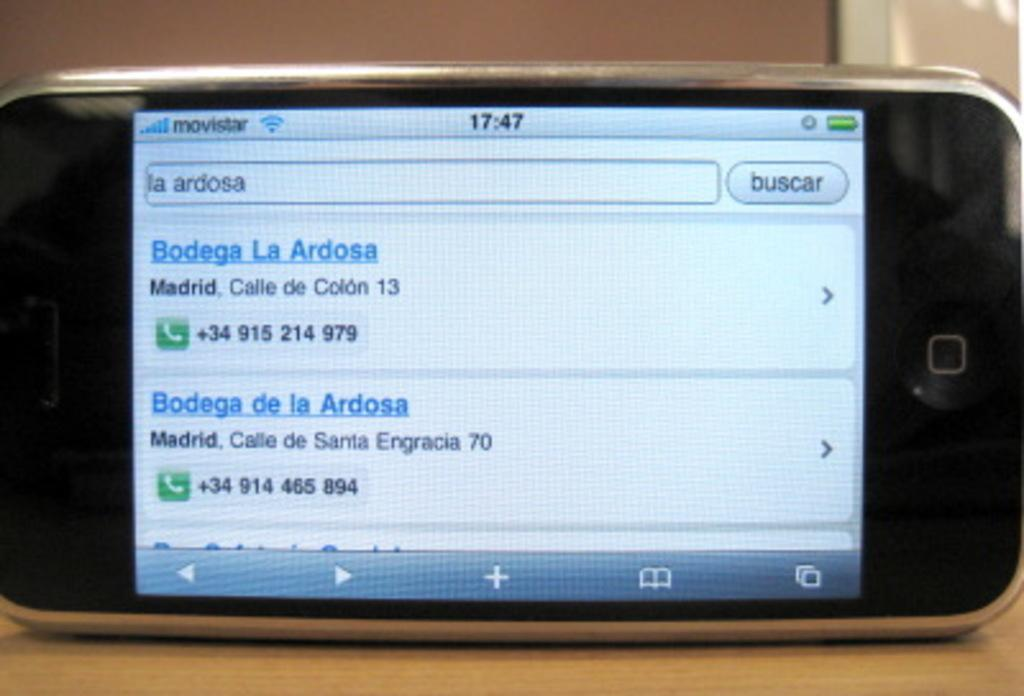<image>
Provide a brief description of the given image. A cellphone screen shows the results of a search for Bodega de la Ardosa. 